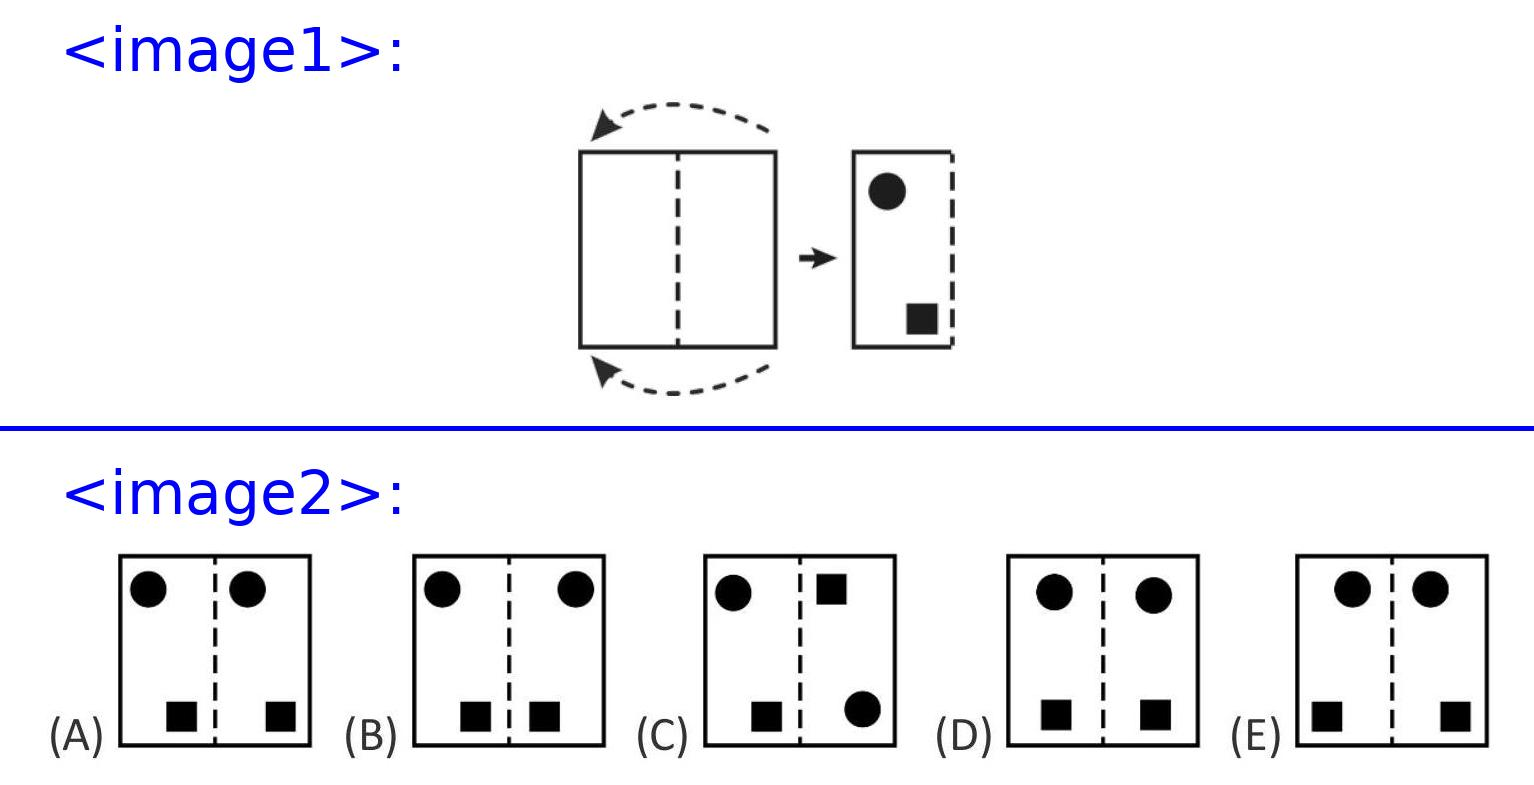Can you explain why Susi's method results in the pattern seen in option B instead of any other option? Certainly! When Susi folds the paper and places a stamp, the holes are punched through both layers of the paper at once. Upon unfolding, these holes mirror each other across the folded line, creating a symmetrical arrangement as seen in option B. The other options either do not reflect this symmetry or position the shapes differently than how Susi's stamping would logically result. 